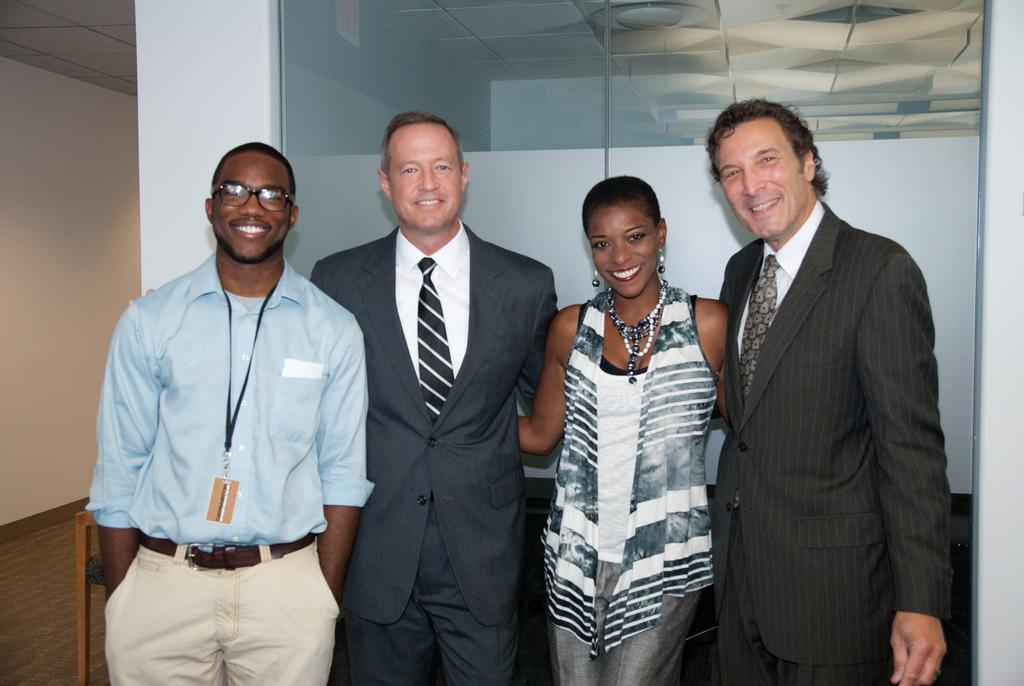How many people are present in the image? There are 4 people in the image. What is the background of the image? The people are standing in front of a glass wall. What is the facial expression of the people in the image? The people are smiling. Can you describe the interaction between the people and their surroundings? The people are likely smiling at someone, although this cannot be confirmed without additional context. What type of cream is being used to decorate the crown in the image? There is no crown or cream present in the image. 